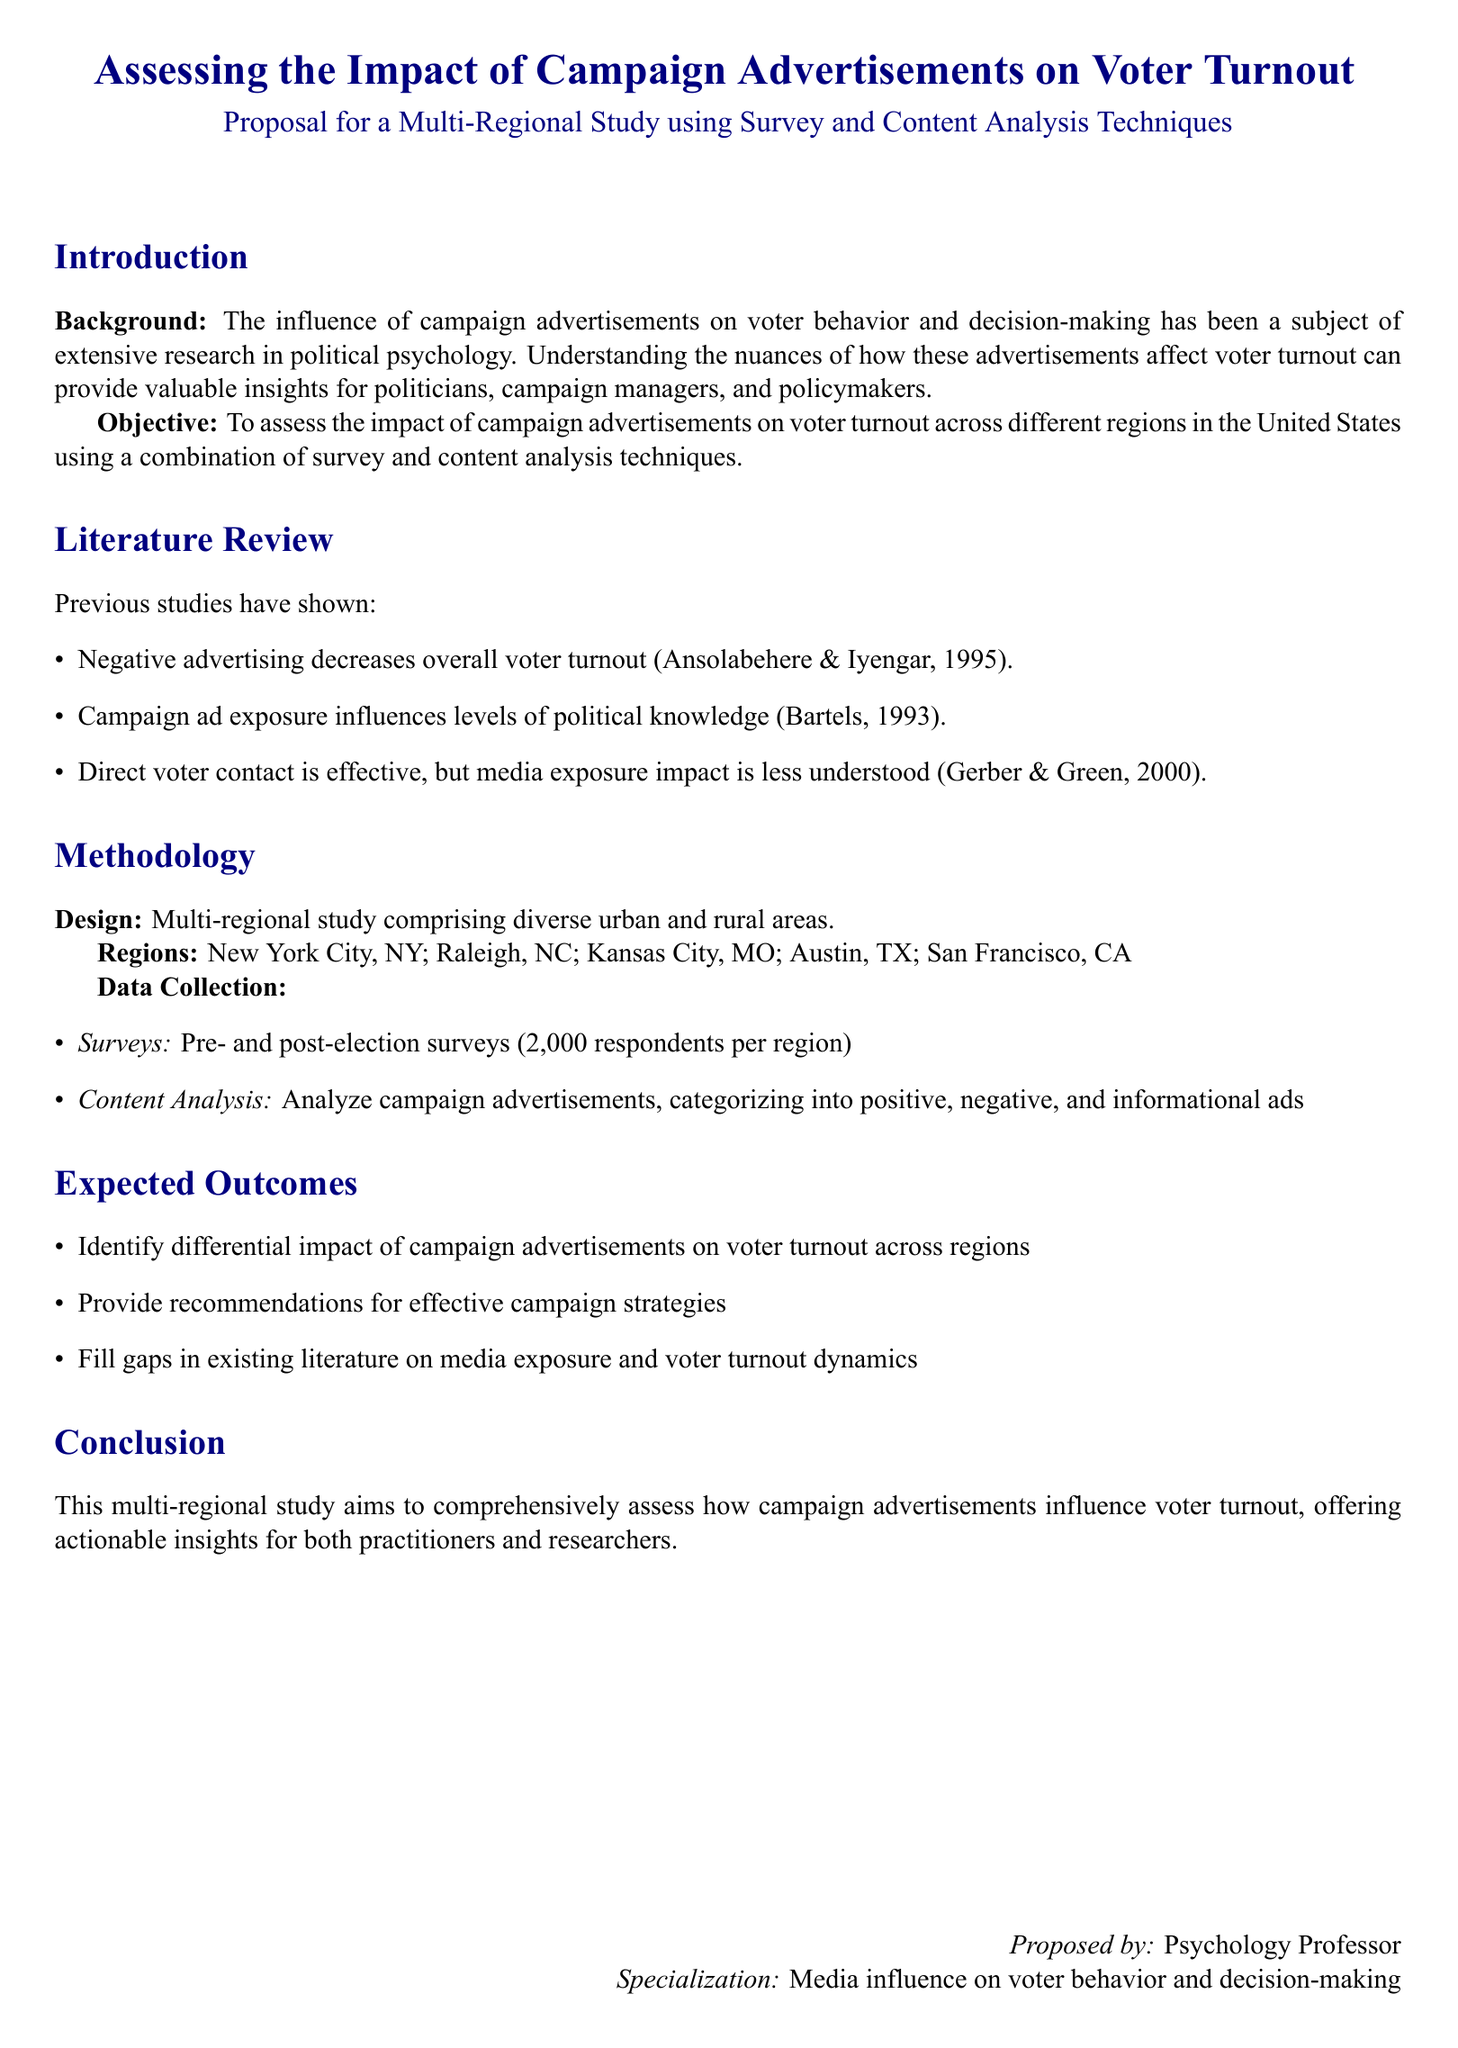What is the main objective of the study? The main objective is to assess the impact of campaign advertisements on voter turnout across different regions in the United States using a combination of survey and content analysis techniques.
Answer: assess the impact of campaign advertisements on voter turnout How many respondents will be surveyed in each region? The document states that there will be 2,000 respondents per region in the pre- and post-election surveys.
Answer: 2000 respondents Which regions are included in the study? The regions listed in the proposal are New York City, NY; Raleigh, NC; Kansas City, MO; Austin, TX; San Francisco, CA.
Answer: New York City, NY; Raleigh, NC; Kansas City, MO; Austin, TX; San Francisco, CA What type of analysis will be employed to assess the advertisements? The proposal mentions the use of content analysis to categorize the campaign advertisements.
Answer: content analysis What is one expected outcome of the study? One expected outcome is to provide recommendations for effective campaign strategies.
Answer: recommendations for effective campaign strategies Which theory does the proposal reference regarding negative advertising? The study references Ansolabehere and Iyengar's (1995) findings on the influence of negative advertising.
Answer: Ansolabehere and Iyengar (1995) What method will be used alongside surveys in this study? Content analysis will be used alongside surveys to assess the impact of advertisements.
Answer: content analysis What does the study aim to fill gaps in? The study aims to fill gaps in existing literature on media exposure and voter turnout dynamics.
Answer: existing literature on media exposure and voter turnout dynamics 